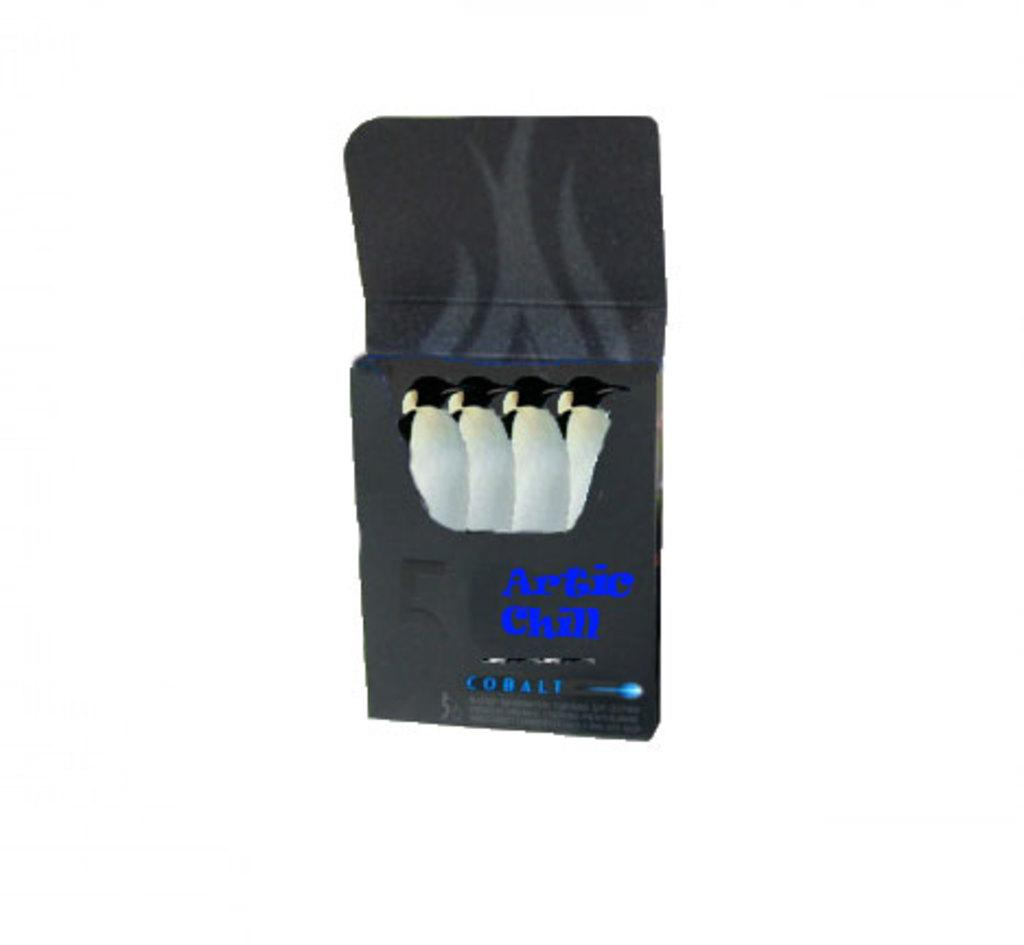<image>
Present a compact description of the photo's key features. A black box of penguins says Artic Chill Cobalt. 